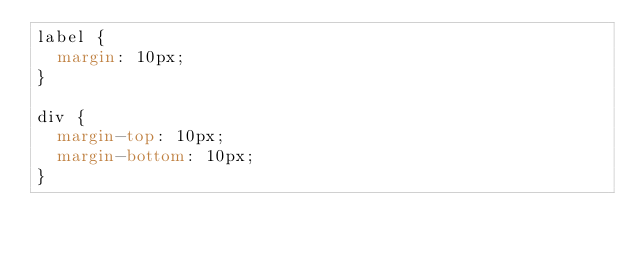<code> <loc_0><loc_0><loc_500><loc_500><_CSS_>label {
	margin: 10px;
}

div {
	margin-top: 10px;
	margin-bottom: 10px;
}</code> 